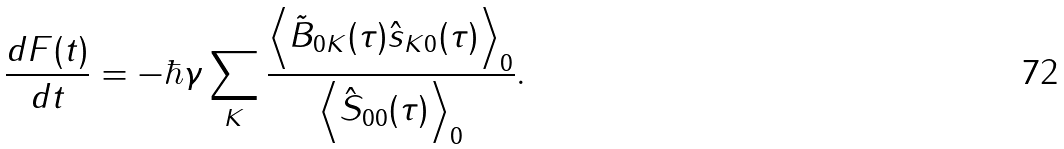<formula> <loc_0><loc_0><loc_500><loc_500>\frac { d F ( t ) } { d t } = - \hbar { \gamma } \sum _ { K } \frac { \Big < \tilde { B } _ { 0 K } ( \tau ) \hat { s } _ { K 0 } ( \tau ) \Big > _ { 0 } } { \Big < \hat { S } _ { 0 0 } ( \tau ) \Big > _ { 0 } } .</formula> 